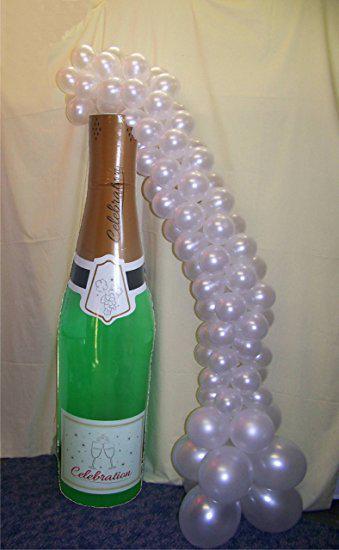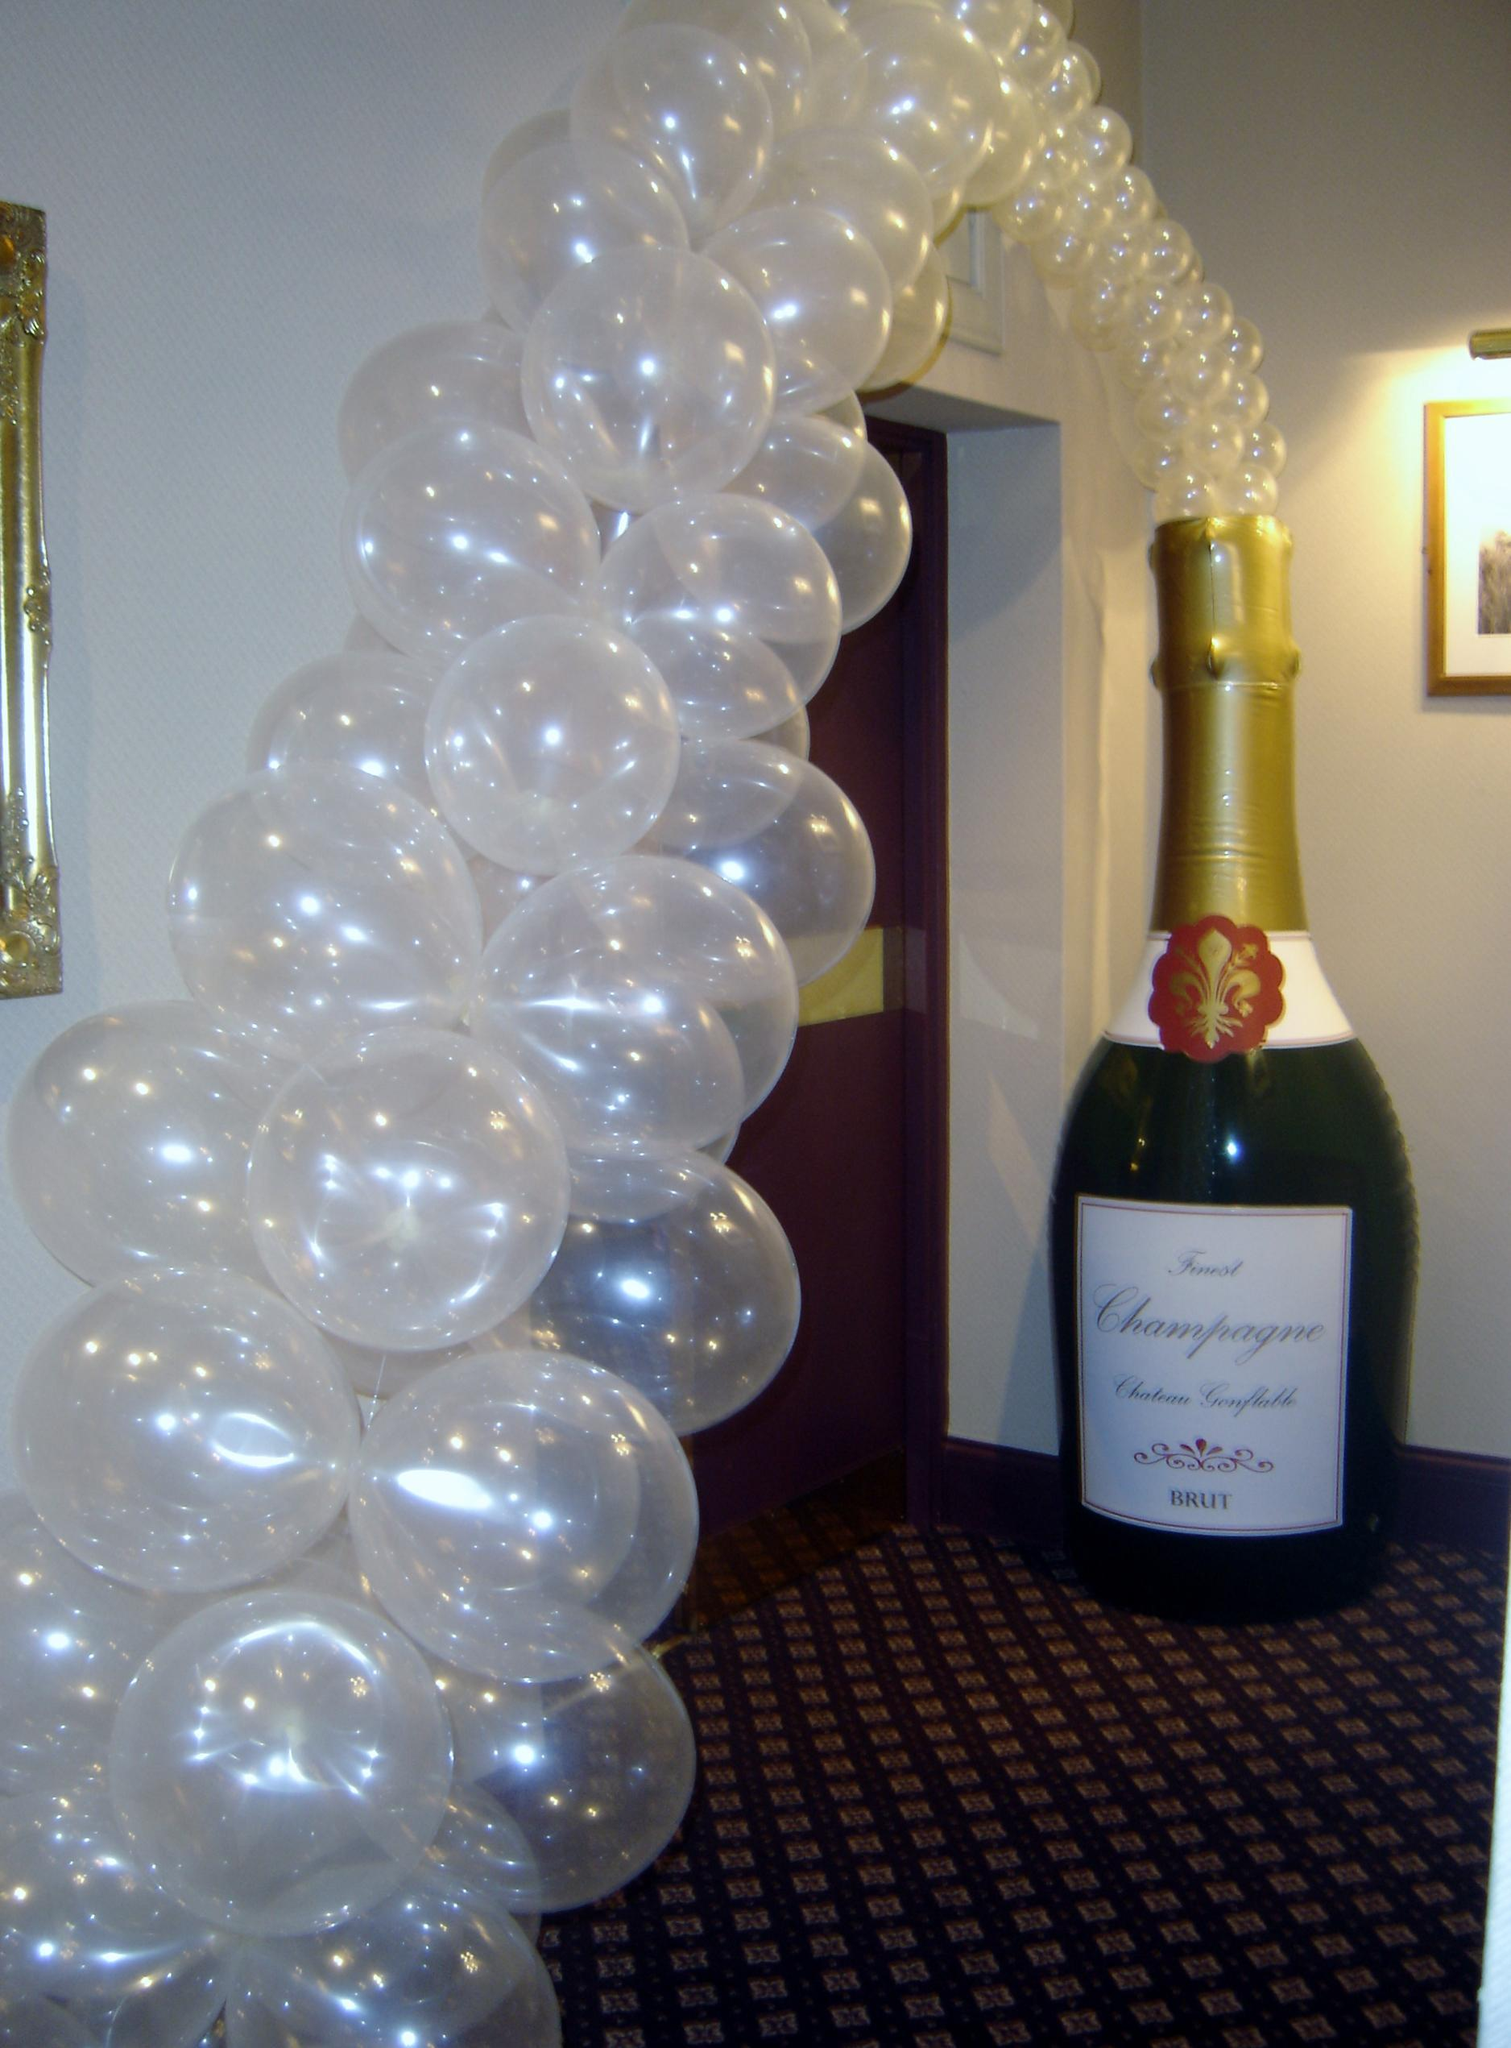The first image is the image on the left, the second image is the image on the right. Evaluate the accuracy of this statement regarding the images: "A bottle is on the right side of a door.". Is it true? Answer yes or no. Yes. The first image is the image on the left, the second image is the image on the right. Analyze the images presented: Is the assertion "There is a white arch of balloons that attached to a big bottle that is over an entrance door." valid? Answer yes or no. Yes. 